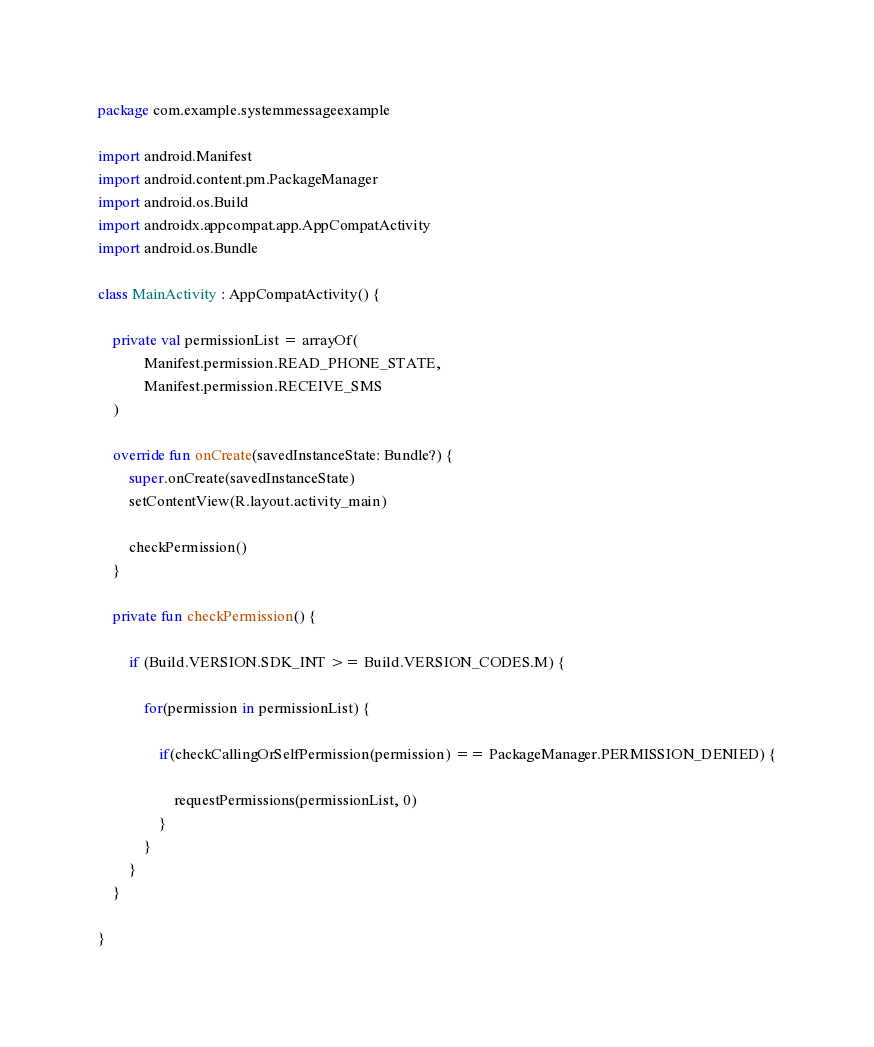<code> <loc_0><loc_0><loc_500><loc_500><_Kotlin_>package com.example.systemmessageexample

import android.Manifest
import android.content.pm.PackageManager
import android.os.Build
import androidx.appcompat.app.AppCompatActivity
import android.os.Bundle

class MainActivity : AppCompatActivity() {

    private val permissionList = arrayOf(
            Manifest.permission.READ_PHONE_STATE,
            Manifest.permission.RECEIVE_SMS
    )

    override fun onCreate(savedInstanceState: Bundle?) {
        super.onCreate(savedInstanceState)
        setContentView(R.layout.activity_main)

        checkPermission()
    }

    private fun checkPermission() {

        if (Build.VERSION.SDK_INT >= Build.VERSION_CODES.M) {

            for(permission in permissionList) {

                if(checkCallingOrSelfPermission(permission) == PackageManager.PERMISSION_DENIED) {

                    requestPermissions(permissionList, 0)
                }
            }
        }
    }

}</code> 